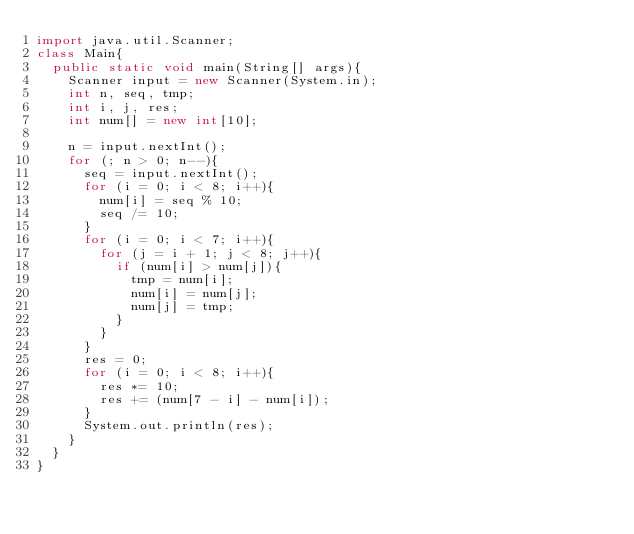<code> <loc_0><loc_0><loc_500><loc_500><_Java_>import java.util.Scanner;
class Main{
	public static void main(String[] args){
		Scanner input = new Scanner(System.in);
		int n, seq, tmp;
		int i, j, res;
		int num[] = new int[10];
		
		n = input.nextInt();
		for (; n > 0; n--){
			seq = input.nextInt();
			for (i = 0; i < 8; i++){
				num[i] = seq % 10;
				seq /= 10;
			}
			for (i = 0; i < 7; i++){
				for (j = i + 1; j < 8; j++){
					if (num[i] > num[j]){
						tmp = num[i];
						num[i] = num[j];
						num[j] = tmp;
					}
				}
			}
			res = 0;
			for (i = 0; i < 8; i++){
				res *= 10;
				res += (num[7 - i] - num[i]);
			}
			System.out.println(res);
		}
	}
}</code> 